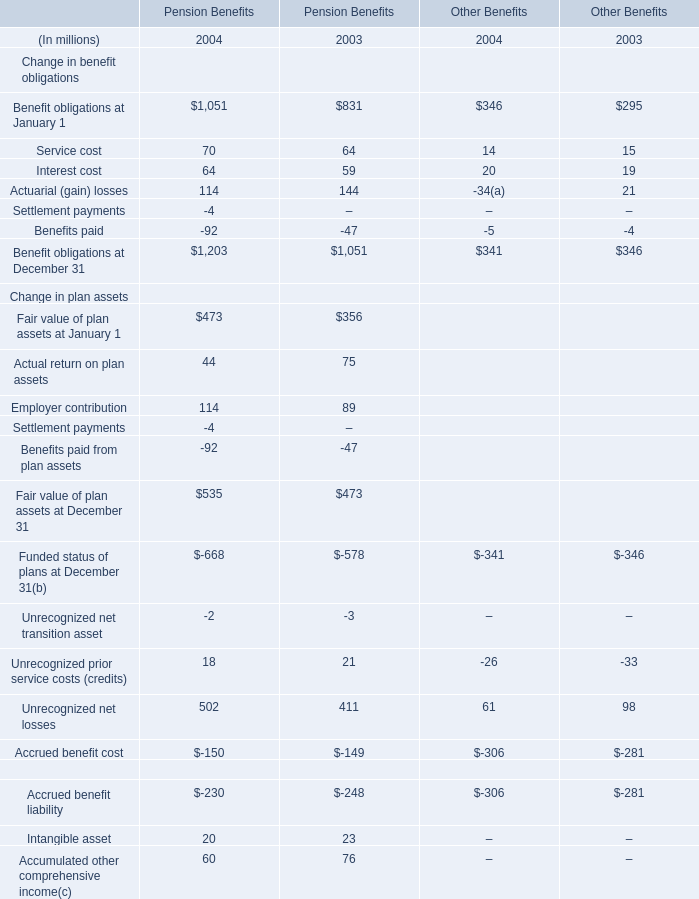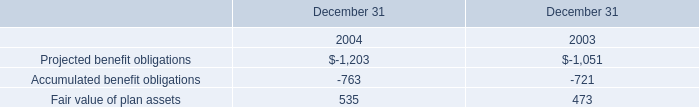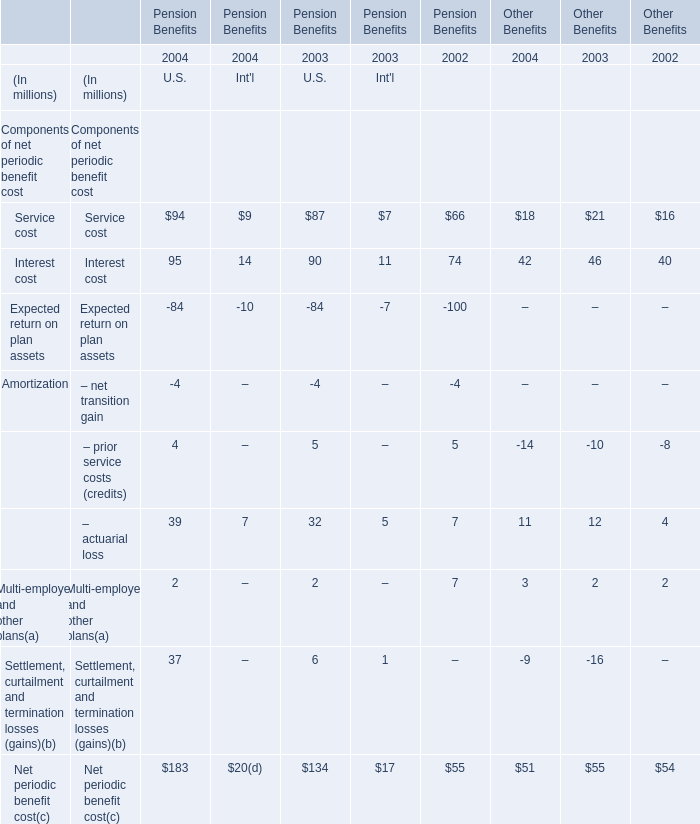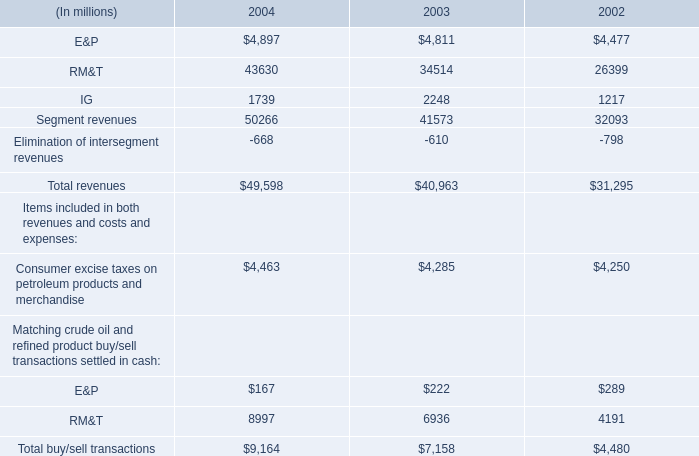What is the difference between 2004 an d 2003 's highest element for U.S.? (in million) 
Computations: (95 - 90)
Answer: 5.0. At January 1,what year is Fair value of plan assets for Pension Benefits higher? 
Answer: 2004. In the section with lowest amount of Interest cost what's the increasing rate of Service cost for Pension Benefits? 
Computations: ((9 - 7) / 7)
Answer: 0.28571. 